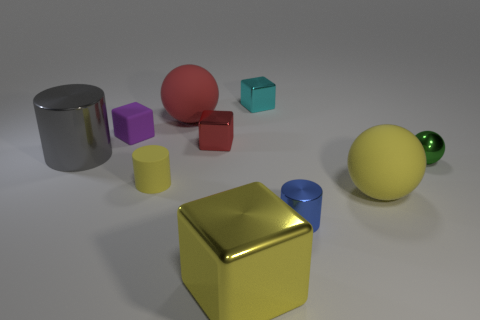Subtract all gray cylinders. How many cylinders are left? 2 Subtract all small cylinders. How many cylinders are left? 1 Subtract all balls. How many objects are left? 7 Subtract all big brown rubber things. Subtract all red spheres. How many objects are left? 9 Add 1 blue metallic objects. How many blue metallic objects are left? 2 Add 7 green metal things. How many green metal things exist? 8 Subtract 1 red cubes. How many objects are left? 9 Subtract 3 blocks. How many blocks are left? 1 Subtract all yellow cubes. Subtract all cyan spheres. How many cubes are left? 3 Subtract all yellow cylinders. How many yellow cubes are left? 1 